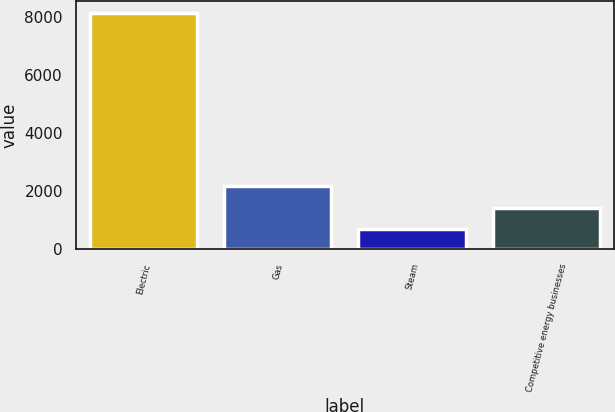<chart> <loc_0><loc_0><loc_500><loc_500><bar_chart><fcel>Electric<fcel>Gas<fcel>Steam<fcel>Competitive energy businesses<nl><fcel>8131<fcel>2172.6<fcel>683<fcel>1427.8<nl></chart> 